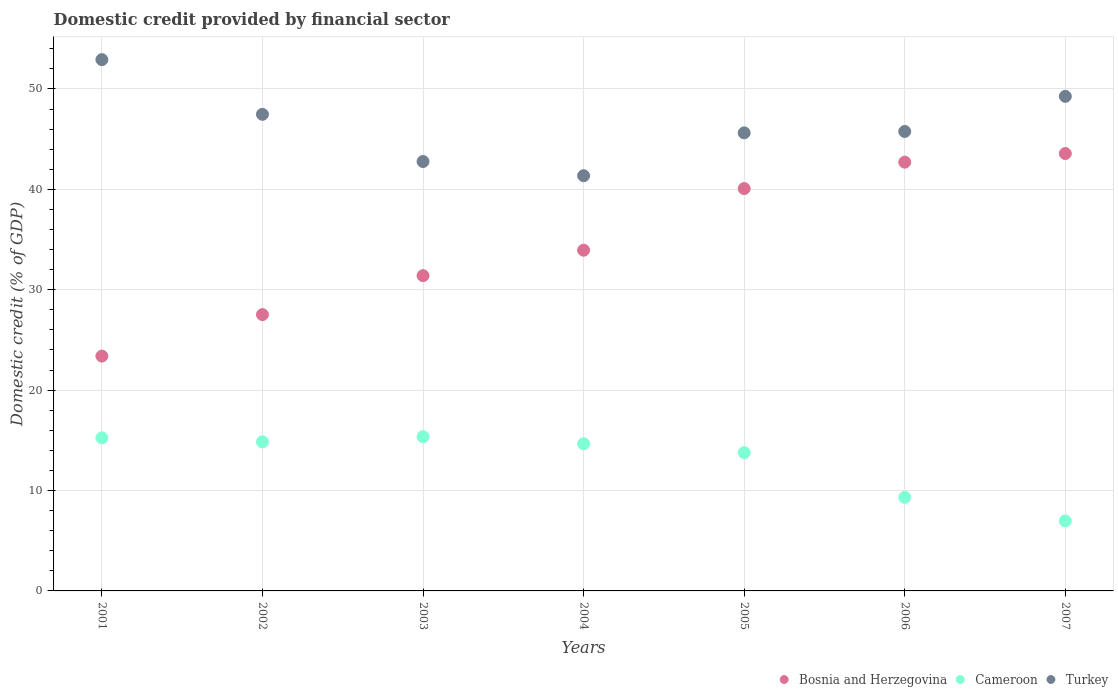Is the number of dotlines equal to the number of legend labels?
Ensure brevity in your answer.  Yes. What is the domestic credit in Turkey in 2001?
Your answer should be compact. 52.92. Across all years, what is the maximum domestic credit in Turkey?
Make the answer very short. 52.92. Across all years, what is the minimum domestic credit in Cameroon?
Your answer should be very brief. 6.97. In which year was the domestic credit in Bosnia and Herzegovina maximum?
Make the answer very short. 2007. In which year was the domestic credit in Turkey minimum?
Ensure brevity in your answer.  2004. What is the total domestic credit in Turkey in the graph?
Offer a terse response. 325.19. What is the difference between the domestic credit in Bosnia and Herzegovina in 2001 and that in 2006?
Your answer should be very brief. -19.32. What is the difference between the domestic credit in Turkey in 2006 and the domestic credit in Cameroon in 2005?
Ensure brevity in your answer.  31.99. What is the average domestic credit in Bosnia and Herzegovina per year?
Ensure brevity in your answer.  34.66. In the year 2006, what is the difference between the domestic credit in Cameroon and domestic credit in Bosnia and Herzegovina?
Ensure brevity in your answer.  -33.39. In how many years, is the domestic credit in Cameroon greater than 4 %?
Offer a very short reply. 7. What is the ratio of the domestic credit in Turkey in 2001 to that in 2004?
Your answer should be compact. 1.28. Is the domestic credit in Bosnia and Herzegovina in 2001 less than that in 2002?
Offer a terse response. Yes. What is the difference between the highest and the second highest domestic credit in Turkey?
Ensure brevity in your answer.  3.66. What is the difference between the highest and the lowest domestic credit in Cameroon?
Provide a short and direct response. 8.39. In how many years, is the domestic credit in Bosnia and Herzegovina greater than the average domestic credit in Bosnia and Herzegovina taken over all years?
Your response must be concise. 3. Is the sum of the domestic credit in Cameroon in 2003 and 2004 greater than the maximum domestic credit in Turkey across all years?
Your answer should be compact. No. Is it the case that in every year, the sum of the domestic credit in Cameroon and domestic credit in Turkey  is greater than the domestic credit in Bosnia and Herzegovina?
Provide a short and direct response. Yes. Does the domestic credit in Turkey monotonically increase over the years?
Offer a very short reply. No. How many dotlines are there?
Offer a terse response. 3. How many years are there in the graph?
Give a very brief answer. 7. Where does the legend appear in the graph?
Offer a very short reply. Bottom right. What is the title of the graph?
Make the answer very short. Domestic credit provided by financial sector. Does "Pacific island small states" appear as one of the legend labels in the graph?
Provide a succinct answer. No. What is the label or title of the Y-axis?
Your answer should be compact. Domestic credit (% of GDP). What is the Domestic credit (% of GDP) of Bosnia and Herzegovina in 2001?
Your response must be concise. 23.39. What is the Domestic credit (% of GDP) in Cameroon in 2001?
Offer a very short reply. 15.25. What is the Domestic credit (% of GDP) of Turkey in 2001?
Give a very brief answer. 52.92. What is the Domestic credit (% of GDP) of Bosnia and Herzegovina in 2002?
Offer a very short reply. 27.52. What is the Domestic credit (% of GDP) in Cameroon in 2002?
Your response must be concise. 14.85. What is the Domestic credit (% of GDP) of Turkey in 2002?
Keep it short and to the point. 47.47. What is the Domestic credit (% of GDP) in Bosnia and Herzegovina in 2003?
Make the answer very short. 31.4. What is the Domestic credit (% of GDP) of Cameroon in 2003?
Offer a terse response. 15.36. What is the Domestic credit (% of GDP) in Turkey in 2003?
Provide a succinct answer. 42.77. What is the Domestic credit (% of GDP) in Bosnia and Herzegovina in 2004?
Give a very brief answer. 33.94. What is the Domestic credit (% of GDP) in Cameroon in 2004?
Your answer should be compact. 14.66. What is the Domestic credit (% of GDP) in Turkey in 2004?
Offer a very short reply. 41.36. What is the Domestic credit (% of GDP) in Bosnia and Herzegovina in 2005?
Make the answer very short. 40.08. What is the Domestic credit (% of GDP) in Cameroon in 2005?
Offer a terse response. 13.77. What is the Domestic credit (% of GDP) in Turkey in 2005?
Provide a short and direct response. 45.63. What is the Domestic credit (% of GDP) of Bosnia and Herzegovina in 2006?
Offer a very short reply. 42.71. What is the Domestic credit (% of GDP) in Cameroon in 2006?
Offer a terse response. 9.32. What is the Domestic credit (% of GDP) of Turkey in 2006?
Provide a short and direct response. 45.77. What is the Domestic credit (% of GDP) of Bosnia and Herzegovina in 2007?
Your response must be concise. 43.57. What is the Domestic credit (% of GDP) in Cameroon in 2007?
Your response must be concise. 6.97. What is the Domestic credit (% of GDP) in Turkey in 2007?
Keep it short and to the point. 49.26. Across all years, what is the maximum Domestic credit (% of GDP) of Bosnia and Herzegovina?
Keep it short and to the point. 43.57. Across all years, what is the maximum Domestic credit (% of GDP) in Cameroon?
Provide a succinct answer. 15.36. Across all years, what is the maximum Domestic credit (% of GDP) in Turkey?
Provide a short and direct response. 52.92. Across all years, what is the minimum Domestic credit (% of GDP) in Bosnia and Herzegovina?
Ensure brevity in your answer.  23.39. Across all years, what is the minimum Domestic credit (% of GDP) of Cameroon?
Your answer should be very brief. 6.97. Across all years, what is the minimum Domestic credit (% of GDP) of Turkey?
Ensure brevity in your answer.  41.36. What is the total Domestic credit (% of GDP) of Bosnia and Herzegovina in the graph?
Offer a very short reply. 242.61. What is the total Domestic credit (% of GDP) in Cameroon in the graph?
Provide a succinct answer. 90.19. What is the total Domestic credit (% of GDP) of Turkey in the graph?
Offer a terse response. 325.19. What is the difference between the Domestic credit (% of GDP) in Bosnia and Herzegovina in 2001 and that in 2002?
Keep it short and to the point. -4.13. What is the difference between the Domestic credit (% of GDP) in Cameroon in 2001 and that in 2002?
Your response must be concise. 0.4. What is the difference between the Domestic credit (% of GDP) in Turkey in 2001 and that in 2002?
Your response must be concise. 5.45. What is the difference between the Domestic credit (% of GDP) in Bosnia and Herzegovina in 2001 and that in 2003?
Ensure brevity in your answer.  -8.01. What is the difference between the Domestic credit (% of GDP) in Cameroon in 2001 and that in 2003?
Offer a terse response. -0.11. What is the difference between the Domestic credit (% of GDP) in Turkey in 2001 and that in 2003?
Your answer should be very brief. 10.15. What is the difference between the Domestic credit (% of GDP) in Bosnia and Herzegovina in 2001 and that in 2004?
Keep it short and to the point. -10.55. What is the difference between the Domestic credit (% of GDP) in Cameroon in 2001 and that in 2004?
Ensure brevity in your answer.  0.58. What is the difference between the Domestic credit (% of GDP) in Turkey in 2001 and that in 2004?
Provide a short and direct response. 11.56. What is the difference between the Domestic credit (% of GDP) of Bosnia and Herzegovina in 2001 and that in 2005?
Make the answer very short. -16.69. What is the difference between the Domestic credit (% of GDP) of Cameroon in 2001 and that in 2005?
Provide a succinct answer. 1.47. What is the difference between the Domestic credit (% of GDP) in Turkey in 2001 and that in 2005?
Offer a terse response. 7.29. What is the difference between the Domestic credit (% of GDP) of Bosnia and Herzegovina in 2001 and that in 2006?
Provide a succinct answer. -19.32. What is the difference between the Domestic credit (% of GDP) in Cameroon in 2001 and that in 2006?
Offer a terse response. 5.93. What is the difference between the Domestic credit (% of GDP) in Turkey in 2001 and that in 2006?
Your answer should be very brief. 7.16. What is the difference between the Domestic credit (% of GDP) in Bosnia and Herzegovina in 2001 and that in 2007?
Provide a short and direct response. -20.18. What is the difference between the Domestic credit (% of GDP) in Cameroon in 2001 and that in 2007?
Your response must be concise. 8.28. What is the difference between the Domestic credit (% of GDP) in Turkey in 2001 and that in 2007?
Provide a short and direct response. 3.66. What is the difference between the Domestic credit (% of GDP) in Bosnia and Herzegovina in 2002 and that in 2003?
Ensure brevity in your answer.  -3.88. What is the difference between the Domestic credit (% of GDP) of Cameroon in 2002 and that in 2003?
Make the answer very short. -0.51. What is the difference between the Domestic credit (% of GDP) of Turkey in 2002 and that in 2003?
Keep it short and to the point. 4.7. What is the difference between the Domestic credit (% of GDP) in Bosnia and Herzegovina in 2002 and that in 2004?
Offer a terse response. -6.42. What is the difference between the Domestic credit (% of GDP) in Cameroon in 2002 and that in 2004?
Keep it short and to the point. 0.19. What is the difference between the Domestic credit (% of GDP) of Turkey in 2002 and that in 2004?
Make the answer very short. 6.11. What is the difference between the Domestic credit (% of GDP) in Bosnia and Herzegovina in 2002 and that in 2005?
Make the answer very short. -12.56. What is the difference between the Domestic credit (% of GDP) of Cameroon in 2002 and that in 2005?
Your answer should be compact. 1.08. What is the difference between the Domestic credit (% of GDP) of Turkey in 2002 and that in 2005?
Ensure brevity in your answer.  1.85. What is the difference between the Domestic credit (% of GDP) in Bosnia and Herzegovina in 2002 and that in 2006?
Your answer should be very brief. -15.19. What is the difference between the Domestic credit (% of GDP) of Cameroon in 2002 and that in 2006?
Offer a terse response. 5.53. What is the difference between the Domestic credit (% of GDP) of Turkey in 2002 and that in 2006?
Your answer should be compact. 1.71. What is the difference between the Domestic credit (% of GDP) in Bosnia and Herzegovina in 2002 and that in 2007?
Give a very brief answer. -16.05. What is the difference between the Domestic credit (% of GDP) in Cameroon in 2002 and that in 2007?
Make the answer very short. 7.88. What is the difference between the Domestic credit (% of GDP) in Turkey in 2002 and that in 2007?
Keep it short and to the point. -1.79. What is the difference between the Domestic credit (% of GDP) of Bosnia and Herzegovina in 2003 and that in 2004?
Offer a very short reply. -2.54. What is the difference between the Domestic credit (% of GDP) of Cameroon in 2003 and that in 2004?
Offer a terse response. 0.7. What is the difference between the Domestic credit (% of GDP) in Turkey in 2003 and that in 2004?
Ensure brevity in your answer.  1.41. What is the difference between the Domestic credit (% of GDP) of Bosnia and Herzegovina in 2003 and that in 2005?
Provide a succinct answer. -8.68. What is the difference between the Domestic credit (% of GDP) of Cameroon in 2003 and that in 2005?
Ensure brevity in your answer.  1.58. What is the difference between the Domestic credit (% of GDP) of Turkey in 2003 and that in 2005?
Provide a short and direct response. -2.85. What is the difference between the Domestic credit (% of GDP) of Bosnia and Herzegovina in 2003 and that in 2006?
Offer a terse response. -11.31. What is the difference between the Domestic credit (% of GDP) of Cameroon in 2003 and that in 2006?
Ensure brevity in your answer.  6.04. What is the difference between the Domestic credit (% of GDP) in Turkey in 2003 and that in 2006?
Your answer should be very brief. -2.99. What is the difference between the Domestic credit (% of GDP) of Bosnia and Herzegovina in 2003 and that in 2007?
Offer a very short reply. -12.17. What is the difference between the Domestic credit (% of GDP) in Cameroon in 2003 and that in 2007?
Offer a terse response. 8.39. What is the difference between the Domestic credit (% of GDP) of Turkey in 2003 and that in 2007?
Ensure brevity in your answer.  -6.49. What is the difference between the Domestic credit (% of GDP) of Bosnia and Herzegovina in 2004 and that in 2005?
Offer a very short reply. -6.14. What is the difference between the Domestic credit (% of GDP) of Cameroon in 2004 and that in 2005?
Offer a very short reply. 0.89. What is the difference between the Domestic credit (% of GDP) in Turkey in 2004 and that in 2005?
Offer a very short reply. -4.27. What is the difference between the Domestic credit (% of GDP) of Bosnia and Herzegovina in 2004 and that in 2006?
Give a very brief answer. -8.77. What is the difference between the Domestic credit (% of GDP) in Cameroon in 2004 and that in 2006?
Provide a succinct answer. 5.35. What is the difference between the Domestic credit (% of GDP) in Turkey in 2004 and that in 2006?
Give a very brief answer. -4.41. What is the difference between the Domestic credit (% of GDP) of Bosnia and Herzegovina in 2004 and that in 2007?
Ensure brevity in your answer.  -9.63. What is the difference between the Domestic credit (% of GDP) in Cameroon in 2004 and that in 2007?
Provide a succinct answer. 7.69. What is the difference between the Domestic credit (% of GDP) of Turkey in 2004 and that in 2007?
Give a very brief answer. -7.9. What is the difference between the Domestic credit (% of GDP) in Bosnia and Herzegovina in 2005 and that in 2006?
Ensure brevity in your answer.  -2.63. What is the difference between the Domestic credit (% of GDP) of Cameroon in 2005 and that in 2006?
Provide a succinct answer. 4.46. What is the difference between the Domestic credit (% of GDP) in Turkey in 2005 and that in 2006?
Give a very brief answer. -0.14. What is the difference between the Domestic credit (% of GDP) in Bosnia and Herzegovina in 2005 and that in 2007?
Provide a short and direct response. -3.49. What is the difference between the Domestic credit (% of GDP) of Cameroon in 2005 and that in 2007?
Ensure brevity in your answer.  6.8. What is the difference between the Domestic credit (% of GDP) of Turkey in 2005 and that in 2007?
Ensure brevity in your answer.  -3.64. What is the difference between the Domestic credit (% of GDP) in Bosnia and Herzegovina in 2006 and that in 2007?
Your response must be concise. -0.86. What is the difference between the Domestic credit (% of GDP) of Cameroon in 2006 and that in 2007?
Keep it short and to the point. 2.35. What is the difference between the Domestic credit (% of GDP) in Turkey in 2006 and that in 2007?
Make the answer very short. -3.5. What is the difference between the Domestic credit (% of GDP) of Bosnia and Herzegovina in 2001 and the Domestic credit (% of GDP) of Cameroon in 2002?
Provide a short and direct response. 8.54. What is the difference between the Domestic credit (% of GDP) of Bosnia and Herzegovina in 2001 and the Domestic credit (% of GDP) of Turkey in 2002?
Your answer should be very brief. -24.08. What is the difference between the Domestic credit (% of GDP) of Cameroon in 2001 and the Domestic credit (% of GDP) of Turkey in 2002?
Make the answer very short. -32.23. What is the difference between the Domestic credit (% of GDP) in Bosnia and Herzegovina in 2001 and the Domestic credit (% of GDP) in Cameroon in 2003?
Offer a very short reply. 8.03. What is the difference between the Domestic credit (% of GDP) of Bosnia and Herzegovina in 2001 and the Domestic credit (% of GDP) of Turkey in 2003?
Offer a terse response. -19.38. What is the difference between the Domestic credit (% of GDP) of Cameroon in 2001 and the Domestic credit (% of GDP) of Turkey in 2003?
Your answer should be compact. -27.53. What is the difference between the Domestic credit (% of GDP) in Bosnia and Herzegovina in 2001 and the Domestic credit (% of GDP) in Cameroon in 2004?
Ensure brevity in your answer.  8.73. What is the difference between the Domestic credit (% of GDP) in Bosnia and Herzegovina in 2001 and the Domestic credit (% of GDP) in Turkey in 2004?
Offer a very short reply. -17.97. What is the difference between the Domestic credit (% of GDP) in Cameroon in 2001 and the Domestic credit (% of GDP) in Turkey in 2004?
Your answer should be compact. -26.11. What is the difference between the Domestic credit (% of GDP) in Bosnia and Herzegovina in 2001 and the Domestic credit (% of GDP) in Cameroon in 2005?
Your answer should be compact. 9.62. What is the difference between the Domestic credit (% of GDP) in Bosnia and Herzegovina in 2001 and the Domestic credit (% of GDP) in Turkey in 2005?
Provide a short and direct response. -22.24. What is the difference between the Domestic credit (% of GDP) of Cameroon in 2001 and the Domestic credit (% of GDP) of Turkey in 2005?
Your response must be concise. -30.38. What is the difference between the Domestic credit (% of GDP) of Bosnia and Herzegovina in 2001 and the Domestic credit (% of GDP) of Cameroon in 2006?
Ensure brevity in your answer.  14.07. What is the difference between the Domestic credit (% of GDP) of Bosnia and Herzegovina in 2001 and the Domestic credit (% of GDP) of Turkey in 2006?
Keep it short and to the point. -22.37. What is the difference between the Domestic credit (% of GDP) in Cameroon in 2001 and the Domestic credit (% of GDP) in Turkey in 2006?
Your response must be concise. -30.52. What is the difference between the Domestic credit (% of GDP) of Bosnia and Herzegovina in 2001 and the Domestic credit (% of GDP) of Cameroon in 2007?
Ensure brevity in your answer.  16.42. What is the difference between the Domestic credit (% of GDP) in Bosnia and Herzegovina in 2001 and the Domestic credit (% of GDP) in Turkey in 2007?
Your response must be concise. -25.87. What is the difference between the Domestic credit (% of GDP) in Cameroon in 2001 and the Domestic credit (% of GDP) in Turkey in 2007?
Your answer should be compact. -34.01. What is the difference between the Domestic credit (% of GDP) of Bosnia and Herzegovina in 2002 and the Domestic credit (% of GDP) of Cameroon in 2003?
Your response must be concise. 12.16. What is the difference between the Domestic credit (% of GDP) in Bosnia and Herzegovina in 2002 and the Domestic credit (% of GDP) in Turkey in 2003?
Your answer should be very brief. -15.25. What is the difference between the Domestic credit (% of GDP) in Cameroon in 2002 and the Domestic credit (% of GDP) in Turkey in 2003?
Your response must be concise. -27.92. What is the difference between the Domestic credit (% of GDP) of Bosnia and Herzegovina in 2002 and the Domestic credit (% of GDP) of Cameroon in 2004?
Offer a terse response. 12.86. What is the difference between the Domestic credit (% of GDP) of Bosnia and Herzegovina in 2002 and the Domestic credit (% of GDP) of Turkey in 2004?
Give a very brief answer. -13.84. What is the difference between the Domestic credit (% of GDP) in Cameroon in 2002 and the Domestic credit (% of GDP) in Turkey in 2004?
Your answer should be very brief. -26.51. What is the difference between the Domestic credit (% of GDP) of Bosnia and Herzegovina in 2002 and the Domestic credit (% of GDP) of Cameroon in 2005?
Your answer should be compact. 13.75. What is the difference between the Domestic credit (% of GDP) in Bosnia and Herzegovina in 2002 and the Domestic credit (% of GDP) in Turkey in 2005?
Offer a very short reply. -18.1. What is the difference between the Domestic credit (% of GDP) of Cameroon in 2002 and the Domestic credit (% of GDP) of Turkey in 2005?
Your response must be concise. -30.78. What is the difference between the Domestic credit (% of GDP) in Bosnia and Herzegovina in 2002 and the Domestic credit (% of GDP) in Cameroon in 2006?
Keep it short and to the point. 18.2. What is the difference between the Domestic credit (% of GDP) in Bosnia and Herzegovina in 2002 and the Domestic credit (% of GDP) in Turkey in 2006?
Your answer should be compact. -18.24. What is the difference between the Domestic credit (% of GDP) in Cameroon in 2002 and the Domestic credit (% of GDP) in Turkey in 2006?
Your answer should be compact. -30.91. What is the difference between the Domestic credit (% of GDP) of Bosnia and Herzegovina in 2002 and the Domestic credit (% of GDP) of Cameroon in 2007?
Make the answer very short. 20.55. What is the difference between the Domestic credit (% of GDP) in Bosnia and Herzegovina in 2002 and the Domestic credit (% of GDP) in Turkey in 2007?
Ensure brevity in your answer.  -21.74. What is the difference between the Domestic credit (% of GDP) in Cameroon in 2002 and the Domestic credit (% of GDP) in Turkey in 2007?
Keep it short and to the point. -34.41. What is the difference between the Domestic credit (% of GDP) in Bosnia and Herzegovina in 2003 and the Domestic credit (% of GDP) in Cameroon in 2004?
Ensure brevity in your answer.  16.74. What is the difference between the Domestic credit (% of GDP) in Bosnia and Herzegovina in 2003 and the Domestic credit (% of GDP) in Turkey in 2004?
Keep it short and to the point. -9.96. What is the difference between the Domestic credit (% of GDP) in Cameroon in 2003 and the Domestic credit (% of GDP) in Turkey in 2004?
Offer a very short reply. -26. What is the difference between the Domestic credit (% of GDP) of Bosnia and Herzegovina in 2003 and the Domestic credit (% of GDP) of Cameroon in 2005?
Keep it short and to the point. 17.63. What is the difference between the Domestic credit (% of GDP) of Bosnia and Herzegovina in 2003 and the Domestic credit (% of GDP) of Turkey in 2005?
Ensure brevity in your answer.  -14.23. What is the difference between the Domestic credit (% of GDP) in Cameroon in 2003 and the Domestic credit (% of GDP) in Turkey in 2005?
Make the answer very short. -30.27. What is the difference between the Domestic credit (% of GDP) of Bosnia and Herzegovina in 2003 and the Domestic credit (% of GDP) of Cameroon in 2006?
Offer a terse response. 22.08. What is the difference between the Domestic credit (% of GDP) in Bosnia and Herzegovina in 2003 and the Domestic credit (% of GDP) in Turkey in 2006?
Your answer should be very brief. -14.36. What is the difference between the Domestic credit (% of GDP) of Cameroon in 2003 and the Domestic credit (% of GDP) of Turkey in 2006?
Provide a succinct answer. -30.41. What is the difference between the Domestic credit (% of GDP) in Bosnia and Herzegovina in 2003 and the Domestic credit (% of GDP) in Cameroon in 2007?
Offer a terse response. 24.43. What is the difference between the Domestic credit (% of GDP) in Bosnia and Herzegovina in 2003 and the Domestic credit (% of GDP) in Turkey in 2007?
Offer a very short reply. -17.86. What is the difference between the Domestic credit (% of GDP) of Cameroon in 2003 and the Domestic credit (% of GDP) of Turkey in 2007?
Provide a succinct answer. -33.9. What is the difference between the Domestic credit (% of GDP) of Bosnia and Herzegovina in 2004 and the Domestic credit (% of GDP) of Cameroon in 2005?
Your answer should be compact. 20.16. What is the difference between the Domestic credit (% of GDP) in Bosnia and Herzegovina in 2004 and the Domestic credit (% of GDP) in Turkey in 2005?
Your answer should be very brief. -11.69. What is the difference between the Domestic credit (% of GDP) in Cameroon in 2004 and the Domestic credit (% of GDP) in Turkey in 2005?
Your answer should be very brief. -30.96. What is the difference between the Domestic credit (% of GDP) in Bosnia and Herzegovina in 2004 and the Domestic credit (% of GDP) in Cameroon in 2006?
Offer a very short reply. 24.62. What is the difference between the Domestic credit (% of GDP) in Bosnia and Herzegovina in 2004 and the Domestic credit (% of GDP) in Turkey in 2006?
Offer a very short reply. -11.83. What is the difference between the Domestic credit (% of GDP) of Cameroon in 2004 and the Domestic credit (% of GDP) of Turkey in 2006?
Give a very brief answer. -31.1. What is the difference between the Domestic credit (% of GDP) of Bosnia and Herzegovina in 2004 and the Domestic credit (% of GDP) of Cameroon in 2007?
Ensure brevity in your answer.  26.97. What is the difference between the Domestic credit (% of GDP) of Bosnia and Herzegovina in 2004 and the Domestic credit (% of GDP) of Turkey in 2007?
Ensure brevity in your answer.  -15.32. What is the difference between the Domestic credit (% of GDP) of Cameroon in 2004 and the Domestic credit (% of GDP) of Turkey in 2007?
Provide a succinct answer. -34.6. What is the difference between the Domestic credit (% of GDP) of Bosnia and Herzegovina in 2005 and the Domestic credit (% of GDP) of Cameroon in 2006?
Give a very brief answer. 30.76. What is the difference between the Domestic credit (% of GDP) of Bosnia and Herzegovina in 2005 and the Domestic credit (% of GDP) of Turkey in 2006?
Ensure brevity in your answer.  -5.69. What is the difference between the Domestic credit (% of GDP) in Cameroon in 2005 and the Domestic credit (% of GDP) in Turkey in 2006?
Ensure brevity in your answer.  -31.99. What is the difference between the Domestic credit (% of GDP) of Bosnia and Herzegovina in 2005 and the Domestic credit (% of GDP) of Cameroon in 2007?
Your answer should be compact. 33.11. What is the difference between the Domestic credit (% of GDP) of Bosnia and Herzegovina in 2005 and the Domestic credit (% of GDP) of Turkey in 2007?
Offer a very short reply. -9.18. What is the difference between the Domestic credit (% of GDP) in Cameroon in 2005 and the Domestic credit (% of GDP) in Turkey in 2007?
Your answer should be compact. -35.49. What is the difference between the Domestic credit (% of GDP) of Bosnia and Herzegovina in 2006 and the Domestic credit (% of GDP) of Cameroon in 2007?
Provide a succinct answer. 35.74. What is the difference between the Domestic credit (% of GDP) in Bosnia and Herzegovina in 2006 and the Domestic credit (% of GDP) in Turkey in 2007?
Offer a very short reply. -6.55. What is the difference between the Domestic credit (% of GDP) of Cameroon in 2006 and the Domestic credit (% of GDP) of Turkey in 2007?
Provide a short and direct response. -39.94. What is the average Domestic credit (% of GDP) of Bosnia and Herzegovina per year?
Provide a succinct answer. 34.66. What is the average Domestic credit (% of GDP) of Cameroon per year?
Make the answer very short. 12.88. What is the average Domestic credit (% of GDP) of Turkey per year?
Your answer should be compact. 46.45. In the year 2001, what is the difference between the Domestic credit (% of GDP) in Bosnia and Herzegovina and Domestic credit (% of GDP) in Cameroon?
Keep it short and to the point. 8.14. In the year 2001, what is the difference between the Domestic credit (% of GDP) in Bosnia and Herzegovina and Domestic credit (% of GDP) in Turkey?
Offer a very short reply. -29.53. In the year 2001, what is the difference between the Domestic credit (% of GDP) in Cameroon and Domestic credit (% of GDP) in Turkey?
Your answer should be compact. -37.67. In the year 2002, what is the difference between the Domestic credit (% of GDP) in Bosnia and Herzegovina and Domestic credit (% of GDP) in Cameroon?
Keep it short and to the point. 12.67. In the year 2002, what is the difference between the Domestic credit (% of GDP) in Bosnia and Herzegovina and Domestic credit (% of GDP) in Turkey?
Make the answer very short. -19.95. In the year 2002, what is the difference between the Domestic credit (% of GDP) of Cameroon and Domestic credit (% of GDP) of Turkey?
Your response must be concise. -32.62. In the year 2003, what is the difference between the Domestic credit (% of GDP) in Bosnia and Herzegovina and Domestic credit (% of GDP) in Cameroon?
Your answer should be compact. 16.04. In the year 2003, what is the difference between the Domestic credit (% of GDP) of Bosnia and Herzegovina and Domestic credit (% of GDP) of Turkey?
Provide a short and direct response. -11.37. In the year 2003, what is the difference between the Domestic credit (% of GDP) in Cameroon and Domestic credit (% of GDP) in Turkey?
Your answer should be very brief. -27.42. In the year 2004, what is the difference between the Domestic credit (% of GDP) in Bosnia and Herzegovina and Domestic credit (% of GDP) in Cameroon?
Provide a succinct answer. 19.27. In the year 2004, what is the difference between the Domestic credit (% of GDP) in Bosnia and Herzegovina and Domestic credit (% of GDP) in Turkey?
Provide a succinct answer. -7.42. In the year 2004, what is the difference between the Domestic credit (% of GDP) in Cameroon and Domestic credit (% of GDP) in Turkey?
Provide a short and direct response. -26.7. In the year 2005, what is the difference between the Domestic credit (% of GDP) in Bosnia and Herzegovina and Domestic credit (% of GDP) in Cameroon?
Offer a very short reply. 26.3. In the year 2005, what is the difference between the Domestic credit (% of GDP) in Bosnia and Herzegovina and Domestic credit (% of GDP) in Turkey?
Your answer should be very brief. -5.55. In the year 2005, what is the difference between the Domestic credit (% of GDP) in Cameroon and Domestic credit (% of GDP) in Turkey?
Ensure brevity in your answer.  -31.85. In the year 2006, what is the difference between the Domestic credit (% of GDP) in Bosnia and Herzegovina and Domestic credit (% of GDP) in Cameroon?
Ensure brevity in your answer.  33.39. In the year 2006, what is the difference between the Domestic credit (% of GDP) of Bosnia and Herzegovina and Domestic credit (% of GDP) of Turkey?
Provide a succinct answer. -3.06. In the year 2006, what is the difference between the Domestic credit (% of GDP) of Cameroon and Domestic credit (% of GDP) of Turkey?
Your answer should be very brief. -36.45. In the year 2007, what is the difference between the Domestic credit (% of GDP) in Bosnia and Herzegovina and Domestic credit (% of GDP) in Cameroon?
Provide a short and direct response. 36.6. In the year 2007, what is the difference between the Domestic credit (% of GDP) of Bosnia and Herzegovina and Domestic credit (% of GDP) of Turkey?
Your answer should be very brief. -5.69. In the year 2007, what is the difference between the Domestic credit (% of GDP) in Cameroon and Domestic credit (% of GDP) in Turkey?
Make the answer very short. -42.29. What is the ratio of the Domestic credit (% of GDP) of Bosnia and Herzegovina in 2001 to that in 2002?
Offer a very short reply. 0.85. What is the ratio of the Domestic credit (% of GDP) in Cameroon in 2001 to that in 2002?
Give a very brief answer. 1.03. What is the ratio of the Domestic credit (% of GDP) in Turkey in 2001 to that in 2002?
Your response must be concise. 1.11. What is the ratio of the Domestic credit (% of GDP) of Bosnia and Herzegovina in 2001 to that in 2003?
Make the answer very short. 0.74. What is the ratio of the Domestic credit (% of GDP) of Cameroon in 2001 to that in 2003?
Keep it short and to the point. 0.99. What is the ratio of the Domestic credit (% of GDP) in Turkey in 2001 to that in 2003?
Keep it short and to the point. 1.24. What is the ratio of the Domestic credit (% of GDP) of Bosnia and Herzegovina in 2001 to that in 2004?
Offer a very short reply. 0.69. What is the ratio of the Domestic credit (% of GDP) of Cameroon in 2001 to that in 2004?
Make the answer very short. 1.04. What is the ratio of the Domestic credit (% of GDP) of Turkey in 2001 to that in 2004?
Provide a short and direct response. 1.28. What is the ratio of the Domestic credit (% of GDP) in Bosnia and Herzegovina in 2001 to that in 2005?
Provide a short and direct response. 0.58. What is the ratio of the Domestic credit (% of GDP) of Cameroon in 2001 to that in 2005?
Give a very brief answer. 1.11. What is the ratio of the Domestic credit (% of GDP) in Turkey in 2001 to that in 2005?
Your response must be concise. 1.16. What is the ratio of the Domestic credit (% of GDP) in Bosnia and Herzegovina in 2001 to that in 2006?
Provide a succinct answer. 0.55. What is the ratio of the Domestic credit (% of GDP) in Cameroon in 2001 to that in 2006?
Offer a very short reply. 1.64. What is the ratio of the Domestic credit (% of GDP) of Turkey in 2001 to that in 2006?
Keep it short and to the point. 1.16. What is the ratio of the Domestic credit (% of GDP) of Bosnia and Herzegovina in 2001 to that in 2007?
Provide a succinct answer. 0.54. What is the ratio of the Domestic credit (% of GDP) of Cameroon in 2001 to that in 2007?
Offer a very short reply. 2.19. What is the ratio of the Domestic credit (% of GDP) in Turkey in 2001 to that in 2007?
Offer a very short reply. 1.07. What is the ratio of the Domestic credit (% of GDP) of Bosnia and Herzegovina in 2002 to that in 2003?
Your answer should be compact. 0.88. What is the ratio of the Domestic credit (% of GDP) of Cameroon in 2002 to that in 2003?
Ensure brevity in your answer.  0.97. What is the ratio of the Domestic credit (% of GDP) of Turkey in 2002 to that in 2003?
Ensure brevity in your answer.  1.11. What is the ratio of the Domestic credit (% of GDP) in Bosnia and Herzegovina in 2002 to that in 2004?
Give a very brief answer. 0.81. What is the ratio of the Domestic credit (% of GDP) of Cameroon in 2002 to that in 2004?
Your answer should be very brief. 1.01. What is the ratio of the Domestic credit (% of GDP) in Turkey in 2002 to that in 2004?
Provide a short and direct response. 1.15. What is the ratio of the Domestic credit (% of GDP) in Bosnia and Herzegovina in 2002 to that in 2005?
Offer a very short reply. 0.69. What is the ratio of the Domestic credit (% of GDP) of Cameroon in 2002 to that in 2005?
Keep it short and to the point. 1.08. What is the ratio of the Domestic credit (% of GDP) of Turkey in 2002 to that in 2005?
Provide a succinct answer. 1.04. What is the ratio of the Domestic credit (% of GDP) of Bosnia and Herzegovina in 2002 to that in 2006?
Keep it short and to the point. 0.64. What is the ratio of the Domestic credit (% of GDP) in Cameroon in 2002 to that in 2006?
Your response must be concise. 1.59. What is the ratio of the Domestic credit (% of GDP) of Turkey in 2002 to that in 2006?
Offer a very short reply. 1.04. What is the ratio of the Domestic credit (% of GDP) in Bosnia and Herzegovina in 2002 to that in 2007?
Ensure brevity in your answer.  0.63. What is the ratio of the Domestic credit (% of GDP) of Cameroon in 2002 to that in 2007?
Keep it short and to the point. 2.13. What is the ratio of the Domestic credit (% of GDP) of Turkey in 2002 to that in 2007?
Offer a very short reply. 0.96. What is the ratio of the Domestic credit (% of GDP) of Bosnia and Herzegovina in 2003 to that in 2004?
Your answer should be compact. 0.93. What is the ratio of the Domestic credit (% of GDP) in Cameroon in 2003 to that in 2004?
Provide a short and direct response. 1.05. What is the ratio of the Domestic credit (% of GDP) in Turkey in 2003 to that in 2004?
Your answer should be very brief. 1.03. What is the ratio of the Domestic credit (% of GDP) in Bosnia and Herzegovina in 2003 to that in 2005?
Ensure brevity in your answer.  0.78. What is the ratio of the Domestic credit (% of GDP) of Cameroon in 2003 to that in 2005?
Provide a succinct answer. 1.11. What is the ratio of the Domestic credit (% of GDP) in Turkey in 2003 to that in 2005?
Ensure brevity in your answer.  0.94. What is the ratio of the Domestic credit (% of GDP) in Bosnia and Herzegovina in 2003 to that in 2006?
Offer a terse response. 0.74. What is the ratio of the Domestic credit (% of GDP) of Cameroon in 2003 to that in 2006?
Your answer should be compact. 1.65. What is the ratio of the Domestic credit (% of GDP) in Turkey in 2003 to that in 2006?
Your answer should be compact. 0.93. What is the ratio of the Domestic credit (% of GDP) of Bosnia and Herzegovina in 2003 to that in 2007?
Ensure brevity in your answer.  0.72. What is the ratio of the Domestic credit (% of GDP) of Cameroon in 2003 to that in 2007?
Your answer should be compact. 2.2. What is the ratio of the Domestic credit (% of GDP) of Turkey in 2003 to that in 2007?
Offer a terse response. 0.87. What is the ratio of the Domestic credit (% of GDP) of Bosnia and Herzegovina in 2004 to that in 2005?
Give a very brief answer. 0.85. What is the ratio of the Domestic credit (% of GDP) of Cameroon in 2004 to that in 2005?
Offer a very short reply. 1.06. What is the ratio of the Domestic credit (% of GDP) in Turkey in 2004 to that in 2005?
Your answer should be very brief. 0.91. What is the ratio of the Domestic credit (% of GDP) in Bosnia and Herzegovina in 2004 to that in 2006?
Offer a very short reply. 0.79. What is the ratio of the Domestic credit (% of GDP) of Cameroon in 2004 to that in 2006?
Ensure brevity in your answer.  1.57. What is the ratio of the Domestic credit (% of GDP) in Turkey in 2004 to that in 2006?
Ensure brevity in your answer.  0.9. What is the ratio of the Domestic credit (% of GDP) in Bosnia and Herzegovina in 2004 to that in 2007?
Offer a very short reply. 0.78. What is the ratio of the Domestic credit (% of GDP) in Cameroon in 2004 to that in 2007?
Provide a short and direct response. 2.1. What is the ratio of the Domestic credit (% of GDP) of Turkey in 2004 to that in 2007?
Offer a very short reply. 0.84. What is the ratio of the Domestic credit (% of GDP) of Bosnia and Herzegovina in 2005 to that in 2006?
Keep it short and to the point. 0.94. What is the ratio of the Domestic credit (% of GDP) of Cameroon in 2005 to that in 2006?
Give a very brief answer. 1.48. What is the ratio of the Domestic credit (% of GDP) of Turkey in 2005 to that in 2006?
Your answer should be very brief. 1. What is the ratio of the Domestic credit (% of GDP) in Bosnia and Herzegovina in 2005 to that in 2007?
Keep it short and to the point. 0.92. What is the ratio of the Domestic credit (% of GDP) in Cameroon in 2005 to that in 2007?
Ensure brevity in your answer.  1.98. What is the ratio of the Domestic credit (% of GDP) of Turkey in 2005 to that in 2007?
Offer a very short reply. 0.93. What is the ratio of the Domestic credit (% of GDP) of Bosnia and Herzegovina in 2006 to that in 2007?
Provide a succinct answer. 0.98. What is the ratio of the Domestic credit (% of GDP) of Cameroon in 2006 to that in 2007?
Offer a very short reply. 1.34. What is the ratio of the Domestic credit (% of GDP) of Turkey in 2006 to that in 2007?
Offer a very short reply. 0.93. What is the difference between the highest and the second highest Domestic credit (% of GDP) in Bosnia and Herzegovina?
Offer a very short reply. 0.86. What is the difference between the highest and the second highest Domestic credit (% of GDP) of Cameroon?
Your answer should be very brief. 0.11. What is the difference between the highest and the second highest Domestic credit (% of GDP) in Turkey?
Your answer should be compact. 3.66. What is the difference between the highest and the lowest Domestic credit (% of GDP) of Bosnia and Herzegovina?
Your answer should be very brief. 20.18. What is the difference between the highest and the lowest Domestic credit (% of GDP) of Cameroon?
Provide a short and direct response. 8.39. What is the difference between the highest and the lowest Domestic credit (% of GDP) in Turkey?
Your response must be concise. 11.56. 